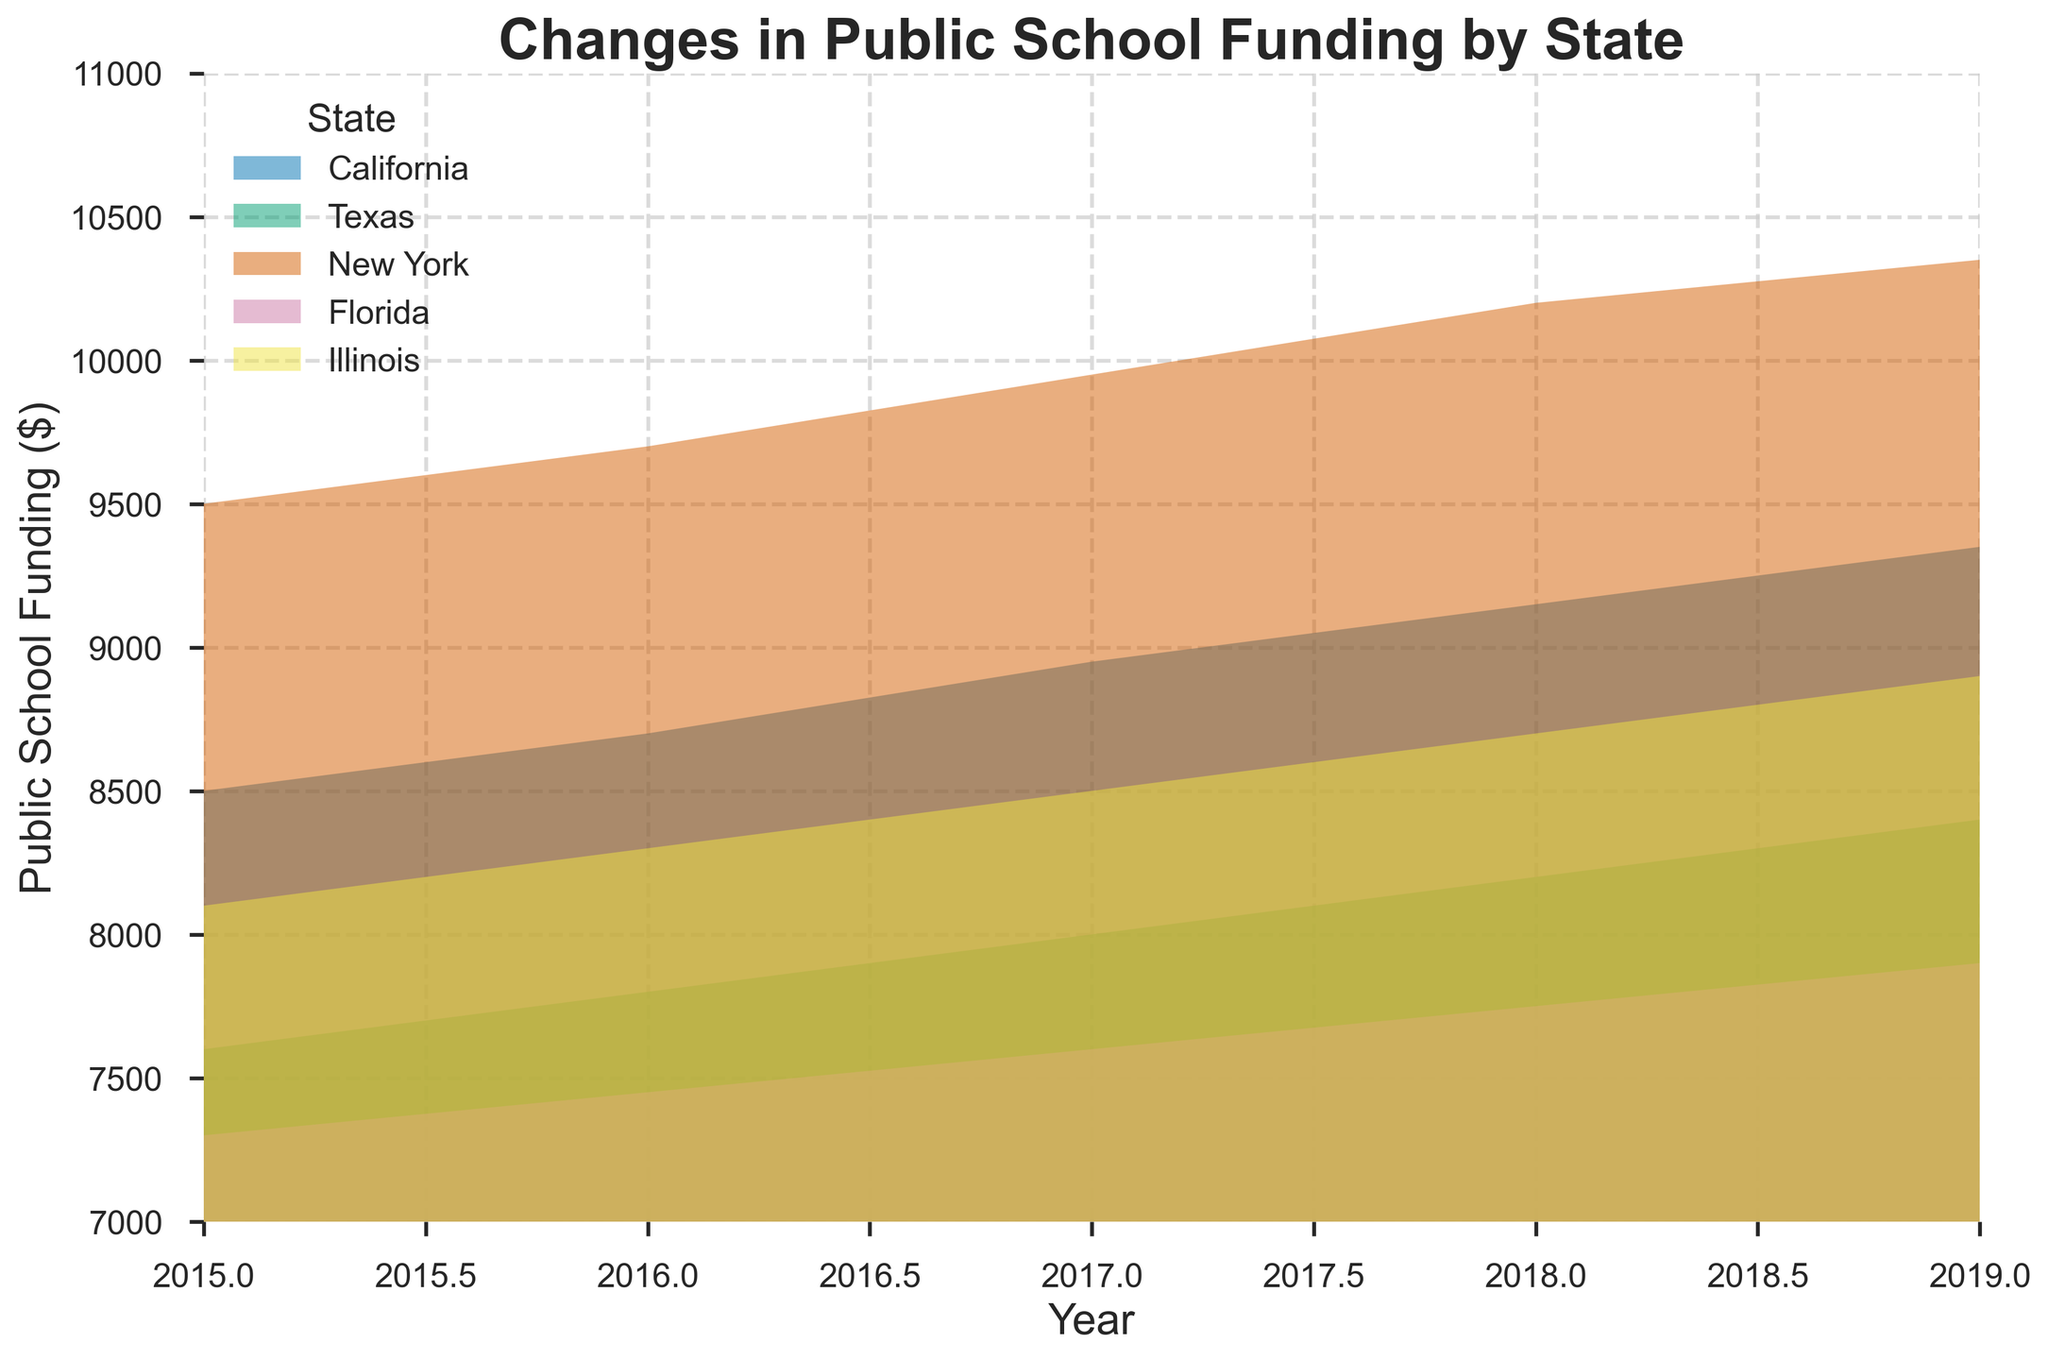What is the title of the chart? The title of the chart is written at the top of the chart in a larger, bold font. It clearly states what the chart is about.
Answer: Changes in Public School Funding by State Which state had the highest public school funding in 2015? To find the highest funding in 2015, look at the leftmost part of the chart for the year 2015, then find the peak area among the different states' colored regions.
Answer: New York What is the range of the y-axis? The y-axis label provides information about the variable representing public school funding and its numeric range.
Answer: 7000 to 11000 Did the public school funding in Texas increase every year from 2015 to 2019? By examining the filled areas for Texas from left to right (2015 to 2019), we can observe if the area is consistently rising.
Answer: Yes What trend do you observe in public school funding in Florida from 2015 to 2019? To identify the trend in Florida, examine how the filled area for Florida changes from 2015 to 2019.
Answer: Increasing Which state showed the highest increase in public school funding from 2015 to 2019? Compare the difference in the height of the filled areas for each state from 2015 to 2019. The state with the largest increase in height represents the highest increase in funding.
Answer: New York How does the academic performance in low-income communities appear to correlate with public school funding among these states? Compare the trend lines of public school funding with academic performance for each state across the years to identify if increases in funding correlate with academic performance improvements.
Answer: Positive correlation Which state had the least increase in public school funding from 2015 to 2019? Calculate the difference in public school funding from 2015 to 2019 for each state and identify the smallest increase.
Answer: Florida What is the average public school funding in California over the years 2015-2019? Sum the public school funding values for California from 2015 to 2019 and divide by the number of years (5).
Answer: 8920 Is there any year when public school funding levels were the same for two different states? Visually inspect the height of the filled areas for each state year by year to see if two states reach the same level in any given year.
Answer: No 